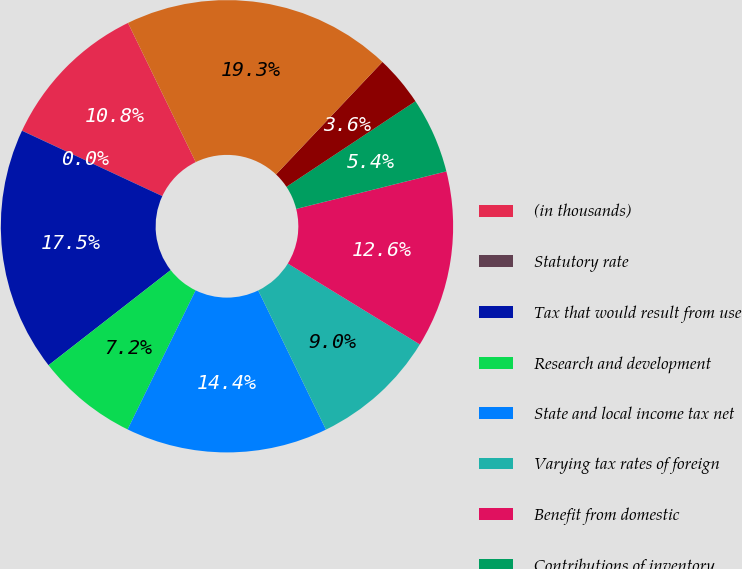<chart> <loc_0><loc_0><loc_500><loc_500><pie_chart><fcel>(in thousands)<fcel>Statutory rate<fcel>Tax that would result from use<fcel>Research and development<fcel>State and local income tax net<fcel>Varying tax rates of foreign<fcel>Benefit from domestic<fcel>Contributions of inventory<fcel>Other<fcel>Recorded tax expense<nl><fcel>10.84%<fcel>0.01%<fcel>17.47%<fcel>7.23%<fcel>14.45%<fcel>9.04%<fcel>12.65%<fcel>5.42%<fcel>3.62%<fcel>19.27%<nl></chart> 